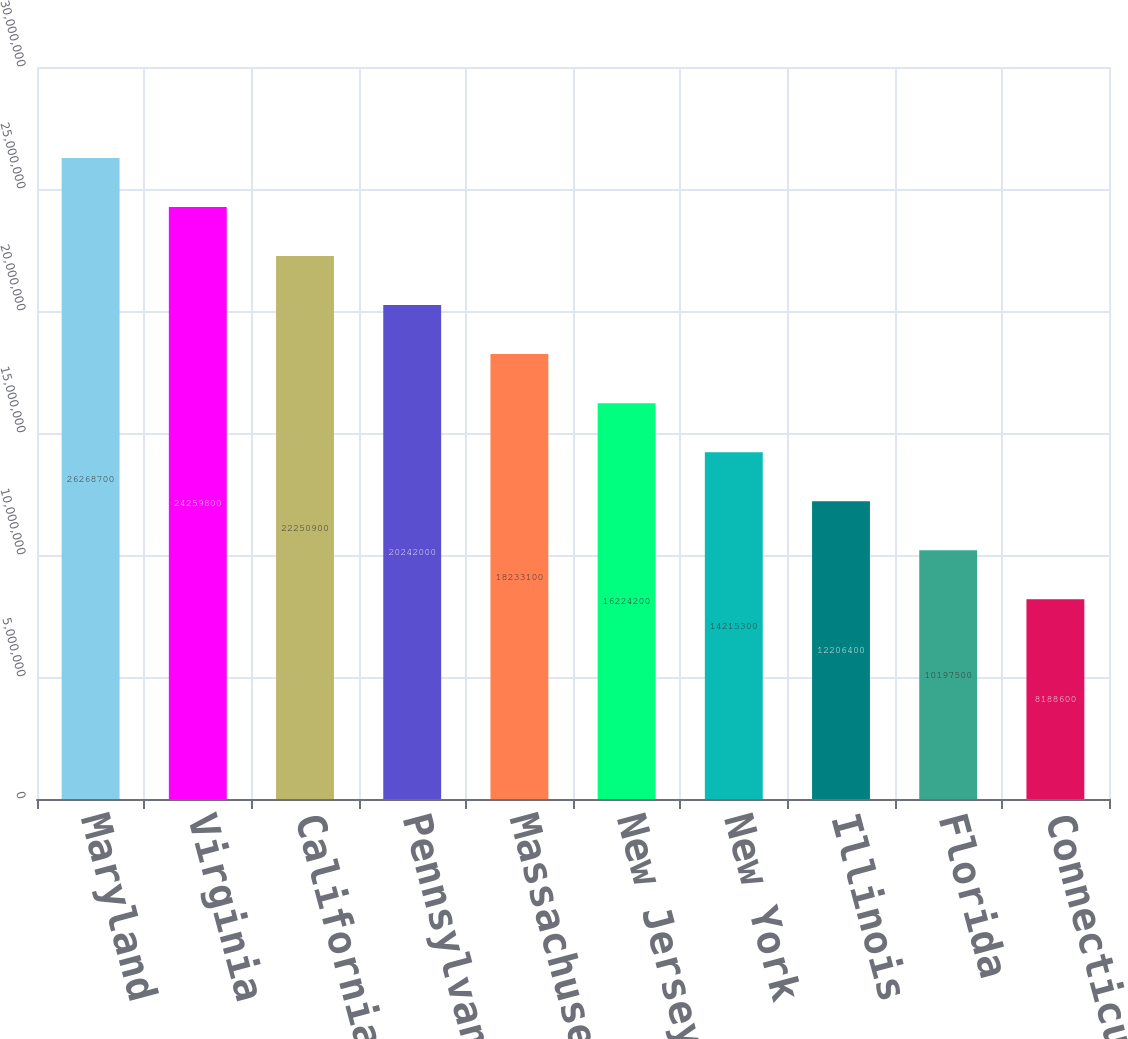<chart> <loc_0><loc_0><loc_500><loc_500><bar_chart><fcel>Maryland<fcel>Virginia<fcel>California<fcel>Pennsylvania(1)<fcel>Massachusetts<fcel>New Jersey<fcel>New York<fcel>Illinois<fcel>Florida<fcel>Connecticut(1)<nl><fcel>2.62687e+07<fcel>2.42598e+07<fcel>2.22509e+07<fcel>2.0242e+07<fcel>1.82331e+07<fcel>1.62242e+07<fcel>1.42153e+07<fcel>1.22064e+07<fcel>1.01975e+07<fcel>8.1886e+06<nl></chart> 